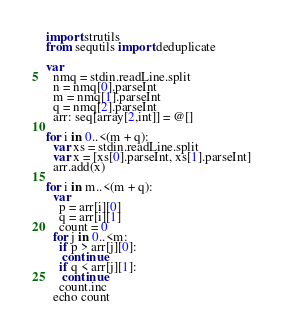Convert code to text. <code><loc_0><loc_0><loc_500><loc_500><_Nim_>import strutils
from sequtils import deduplicate

var
  nmq = stdin.readLine.split
  n = nmq[0].parseInt
  m = nmq[1].parseInt
  q = nmq[2].parseInt
  arr: seq[array[2,int]] = @[]

for i in 0..<(m + q):
  var xs = stdin.readLine.split
  var x = [xs[0].parseInt, xs[1].parseInt]
  arr.add(x)

for i in m..<(m + q):
  var
    p = arr[i][0]
    q = arr[i][1]
    count = 0
  for j in 0..<m:
    if p > arr[j][0]:
     continue
    if q < arr[j][1]:
     continue
    count.inc
  echo count</code> 